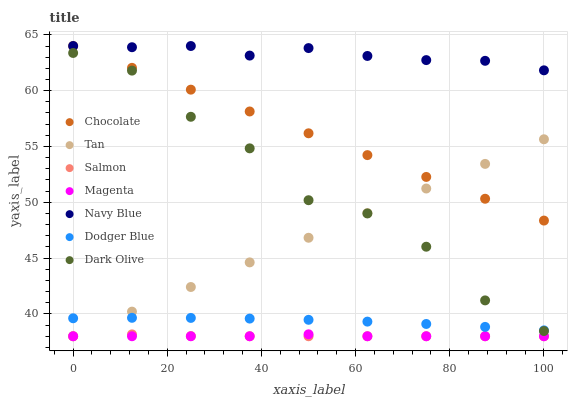Does Magenta have the minimum area under the curve?
Answer yes or no. Yes. Does Navy Blue have the maximum area under the curve?
Answer yes or no. Yes. Does Dark Olive have the minimum area under the curve?
Answer yes or no. No. Does Dark Olive have the maximum area under the curve?
Answer yes or no. No. Is Tan the smoothest?
Answer yes or no. Yes. Is Dark Olive the roughest?
Answer yes or no. Yes. Is Salmon the smoothest?
Answer yes or no. No. Is Salmon the roughest?
Answer yes or no. No. Does Salmon have the lowest value?
Answer yes or no. Yes. Does Dark Olive have the lowest value?
Answer yes or no. No. Does Chocolate have the highest value?
Answer yes or no. Yes. Does Dark Olive have the highest value?
Answer yes or no. No. Is Salmon less than Dark Olive?
Answer yes or no. Yes. Is Dodger Blue greater than Magenta?
Answer yes or no. Yes. Does Dodger Blue intersect Dark Olive?
Answer yes or no. Yes. Is Dodger Blue less than Dark Olive?
Answer yes or no. No. Is Dodger Blue greater than Dark Olive?
Answer yes or no. No. Does Salmon intersect Dark Olive?
Answer yes or no. No. 